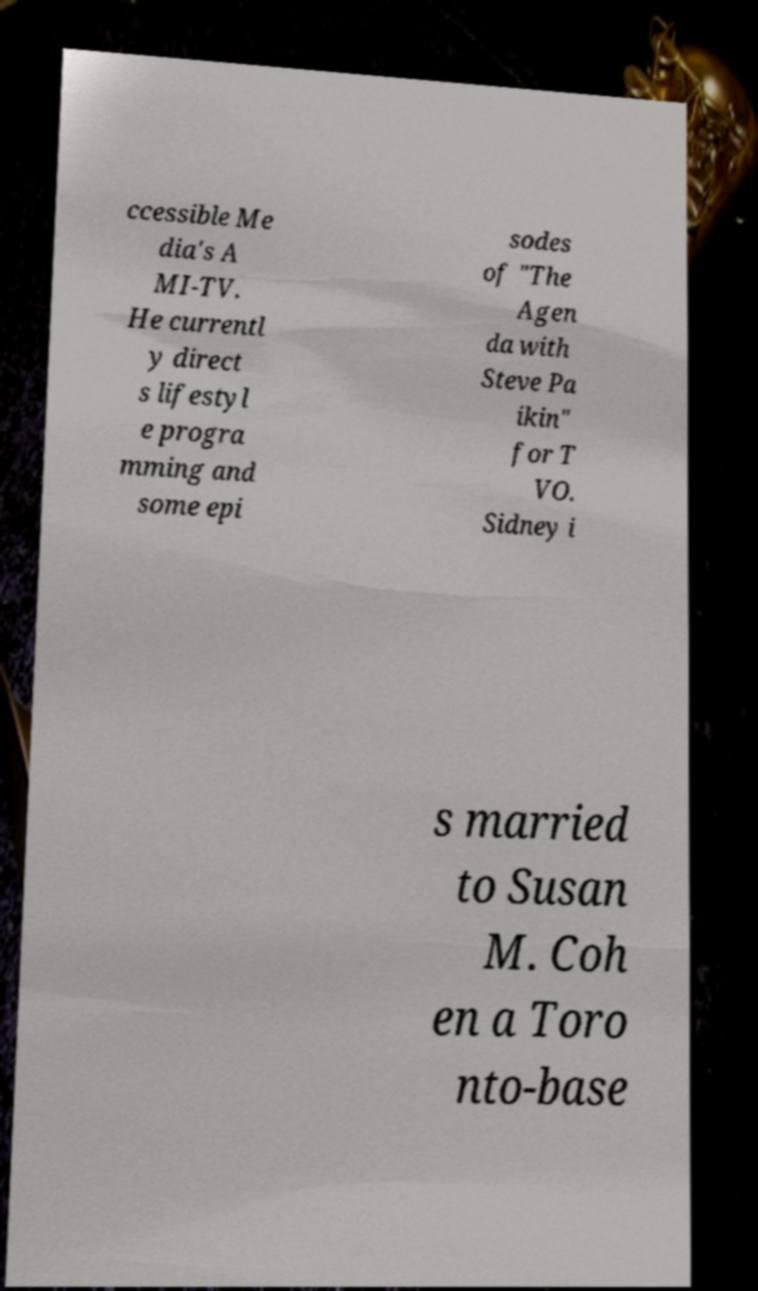I need the written content from this picture converted into text. Can you do that? ccessible Me dia's A MI-TV. He currentl y direct s lifestyl e progra mming and some epi sodes of "The Agen da with Steve Pa ikin" for T VO. Sidney i s married to Susan M. Coh en a Toro nto-base 